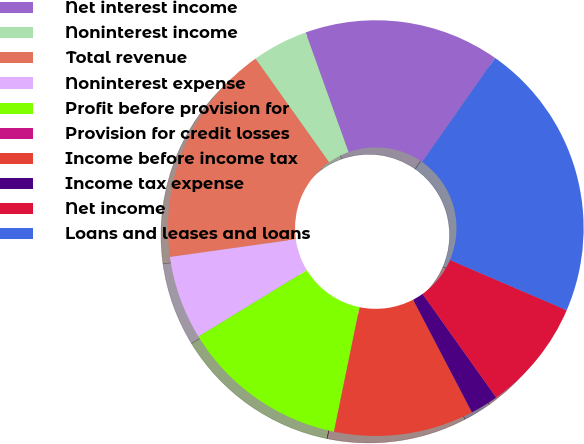<chart> <loc_0><loc_0><loc_500><loc_500><pie_chart><fcel>Net interest income<fcel>Noninterest income<fcel>Total revenue<fcel>Noninterest expense<fcel>Profit before provision for<fcel>Provision for credit losses<fcel>Income before income tax<fcel>Income tax expense<fcel>Net income<fcel>Loans and leases and loans<nl><fcel>15.21%<fcel>4.35%<fcel>17.39%<fcel>6.52%<fcel>13.04%<fcel>0.01%<fcel>10.87%<fcel>2.18%<fcel>8.7%<fcel>21.73%<nl></chart> 